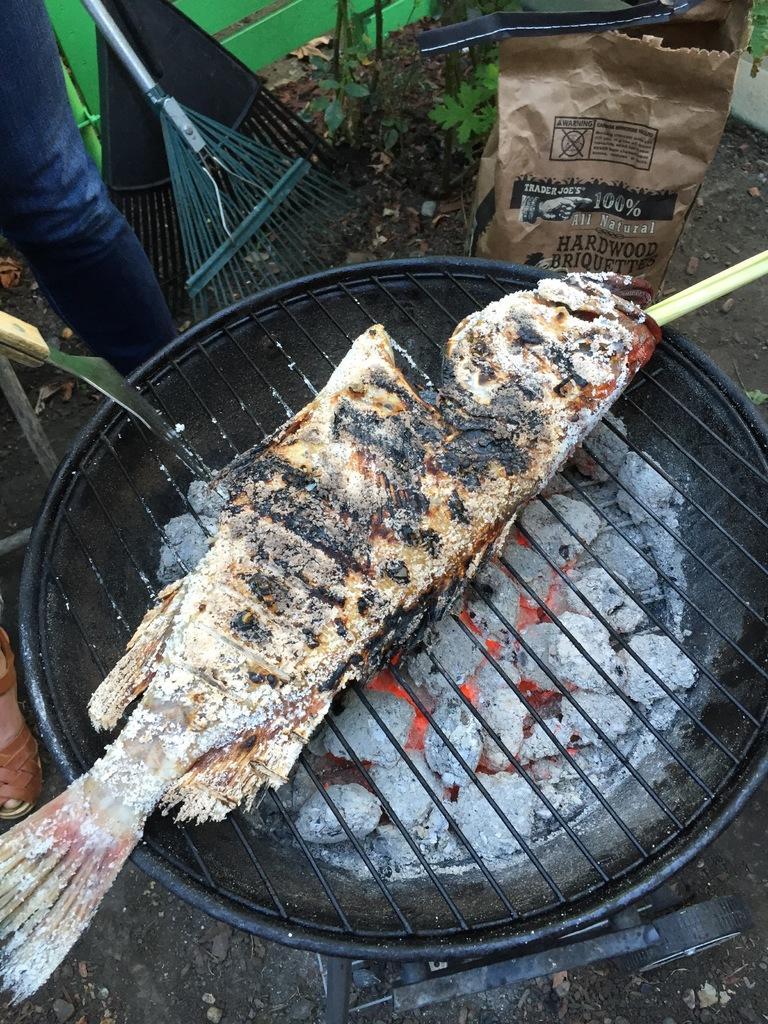Could you give a brief overview of what you see in this image? In this image person is frying the fish on the grill pan. Beside him there are some objects. 